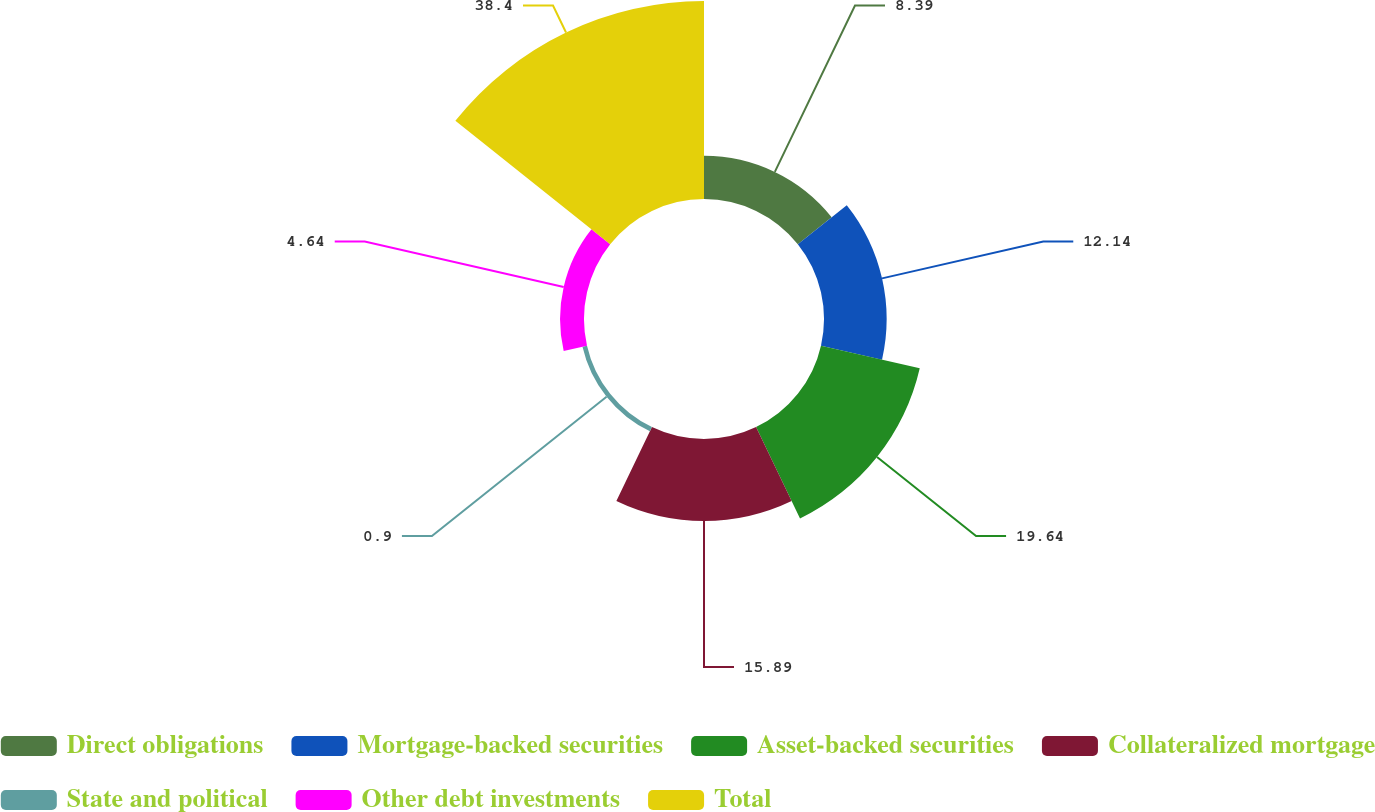Convert chart to OTSL. <chart><loc_0><loc_0><loc_500><loc_500><pie_chart><fcel>Direct obligations<fcel>Mortgage-backed securities<fcel>Asset-backed securities<fcel>Collateralized mortgage<fcel>State and political<fcel>Other debt investments<fcel>Total<nl><fcel>8.39%<fcel>12.14%<fcel>19.64%<fcel>15.89%<fcel>0.9%<fcel>4.64%<fcel>38.39%<nl></chart> 